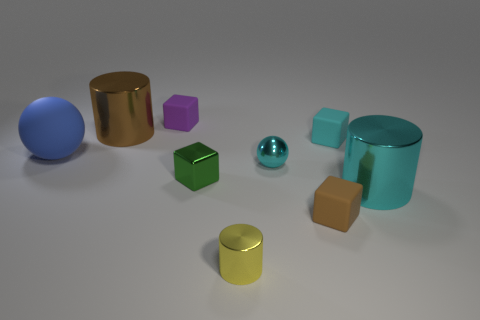Does the large thing right of the brown metallic thing have the same color as the sphere right of the yellow metallic cylinder?
Keep it short and to the point. Yes. The purple object that is the same size as the yellow metallic object is what shape?
Keep it short and to the point. Cube. There is a green object that is the same size as the purple thing; what is its material?
Offer a very short reply. Metal. How many other things are made of the same material as the large cyan thing?
Make the answer very short. 4. What shape is the big blue matte thing that is on the left side of the small matte object in front of the large cyan object?
Give a very brief answer. Sphere. What number of objects are either large brown metal cylinders or cylinders in front of the tiny purple matte thing?
Offer a very short reply. 3. How many other objects are there of the same color as the tiny ball?
Provide a short and direct response. 2. What number of brown objects are either large balls or big metallic spheres?
Ensure brevity in your answer.  0. Is there a large shiny cylinder that is to the right of the metal cylinder behind the metallic cylinder on the right side of the brown matte object?
Offer a very short reply. Yes. There is a metallic cylinder in front of the large metal cylinder that is in front of the large brown cylinder; what is its color?
Offer a very short reply. Yellow. 